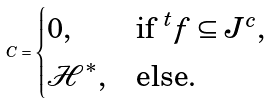<formula> <loc_0><loc_0><loc_500><loc_500>C = \begin{cases} 0 , & \text {if } ^ { t } f \subseteq J ^ { c } , \\ \mathcal { H } ^ { * } , & \text {else} . \end{cases}</formula> 